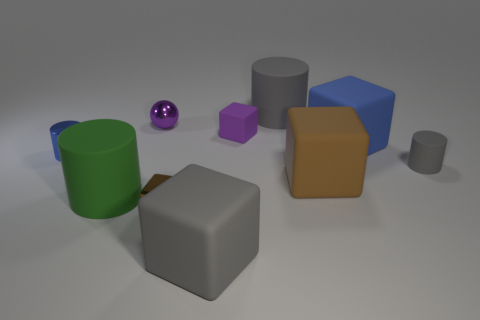What is the size of the block that is the same color as the tiny ball?
Your answer should be very brief. Small. Is there any other thing that has the same color as the shiny sphere?
Your answer should be very brief. Yes. There is a gray cylinder that is in front of the purple matte object; is its size the same as the metal object behind the small blue cylinder?
Your answer should be compact. Yes. Is the number of matte cubes that are behind the small blue cylinder the same as the number of small purple blocks that are to the left of the small purple matte object?
Your answer should be very brief. No. There is a blue cube; does it have the same size as the metal object behind the purple rubber cube?
Keep it short and to the point. No. Are there any big things that are behind the tiny cylinder in front of the small blue cylinder?
Your answer should be very brief. Yes. Are there any gray matte objects that have the same shape as the purple matte thing?
Your answer should be very brief. Yes. There is a brown cube to the left of the purple matte block that is on the left side of the brown rubber block; how many brown metallic objects are behind it?
Your response must be concise. 0. Do the small metal cylinder and the big block that is behind the big brown cube have the same color?
Make the answer very short. Yes. What number of objects are either big cylinders that are to the left of the tiny purple matte thing or rubber cylinders behind the tiny ball?
Provide a succinct answer. 2. 